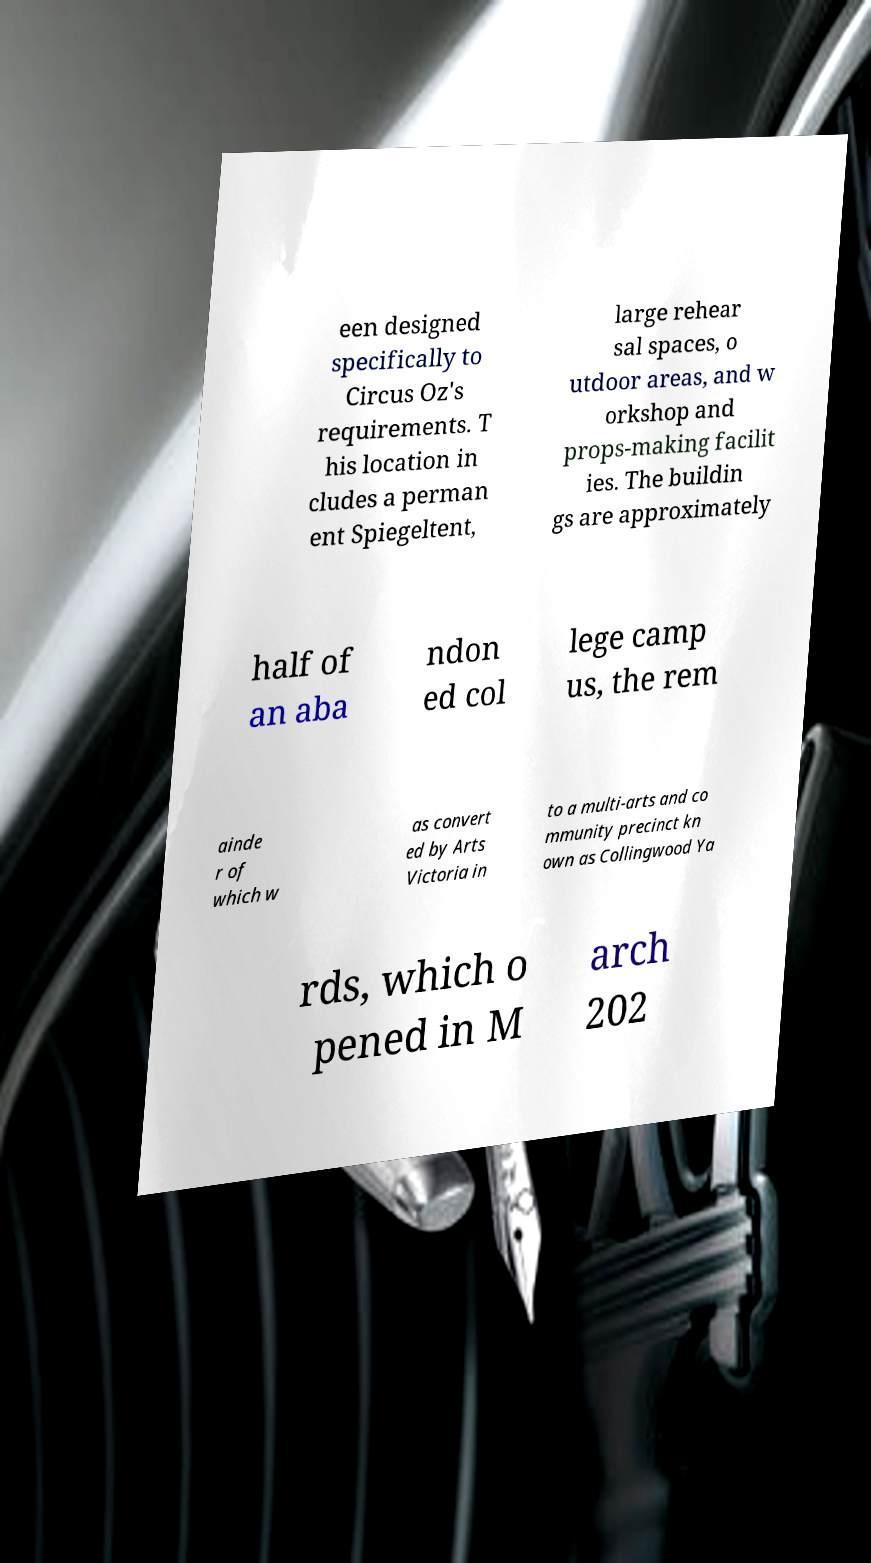Can you accurately transcribe the text from the provided image for me? een designed specifically to Circus Oz's requirements. T his location in cludes a perman ent Spiegeltent, large rehear sal spaces, o utdoor areas, and w orkshop and props-making facilit ies. The buildin gs are approximately half of an aba ndon ed col lege camp us, the rem ainde r of which w as convert ed by Arts Victoria in to a multi-arts and co mmunity precinct kn own as Collingwood Ya rds, which o pened in M arch 202 